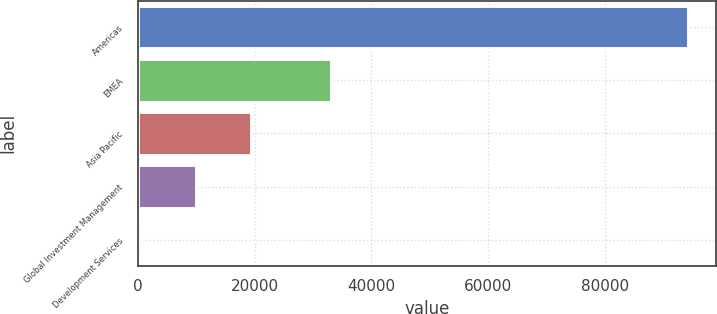Convert chart. <chart><loc_0><loc_0><loc_500><loc_500><bar_chart><fcel>Americas<fcel>EMEA<fcel>Asia Pacific<fcel>Global Investment Management<fcel>Development Services<nl><fcel>94376<fcel>33092<fcel>19296.8<fcel>9911.9<fcel>527<nl></chart> 